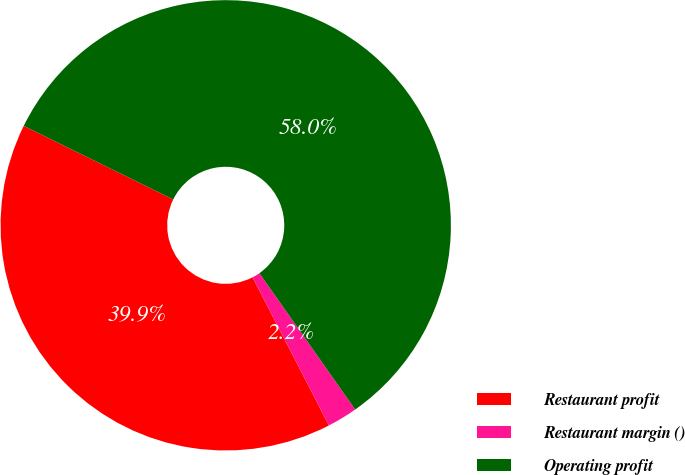Convert chart to OTSL. <chart><loc_0><loc_0><loc_500><loc_500><pie_chart><fcel>Restaurant profit<fcel>Restaurant margin ()<fcel>Operating profit<nl><fcel>39.86%<fcel>2.17%<fcel>57.97%<nl></chart> 